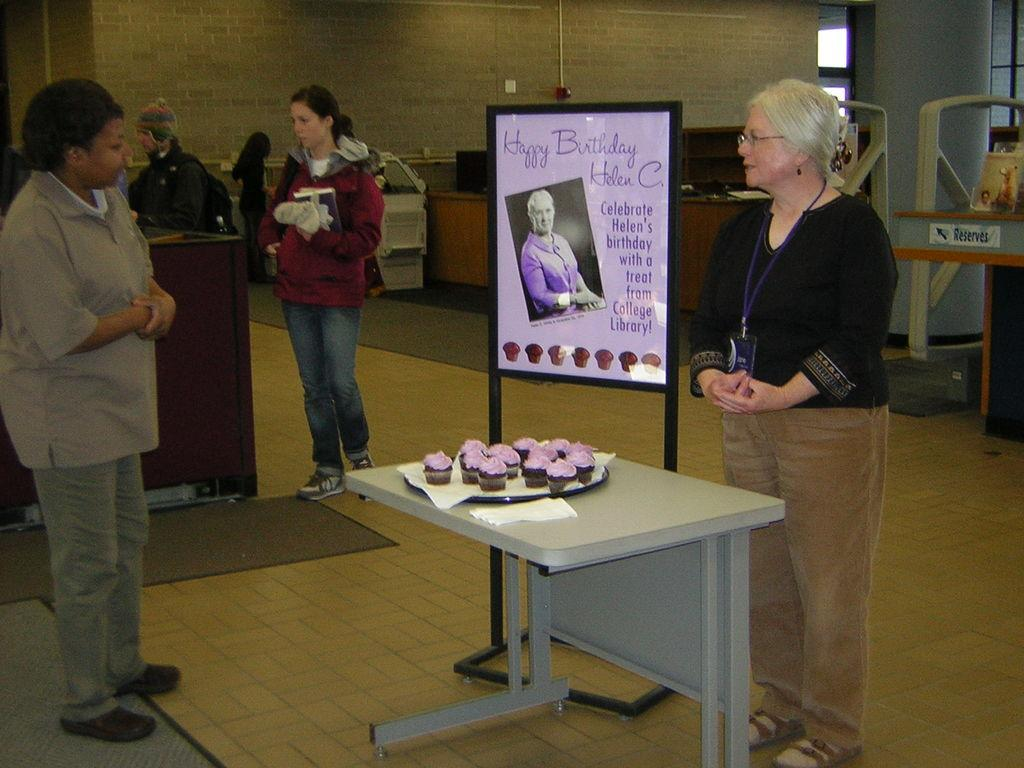What type of structure can be seen in the image? There is a wall in the image. Is there any opening in the wall? Yes, there is a window in the image. What is located near the wall? There is there a table? What are the people in the image doing? People are standing on the floor in the image. Is there any decoration or signage in the image? Yes, there is a banner in the image. Are there any other tables in the image? Yes, there is another table in the front of the image. What is placed on the table in the front? Cupcakes are present on the table. What type of lamp is hanging from the ceiling in the image? There is no lamp present in the image. What thought is being expressed by the people in the image? The image does not convey any thoughts or emotions of the people; it only shows their physical presence. 